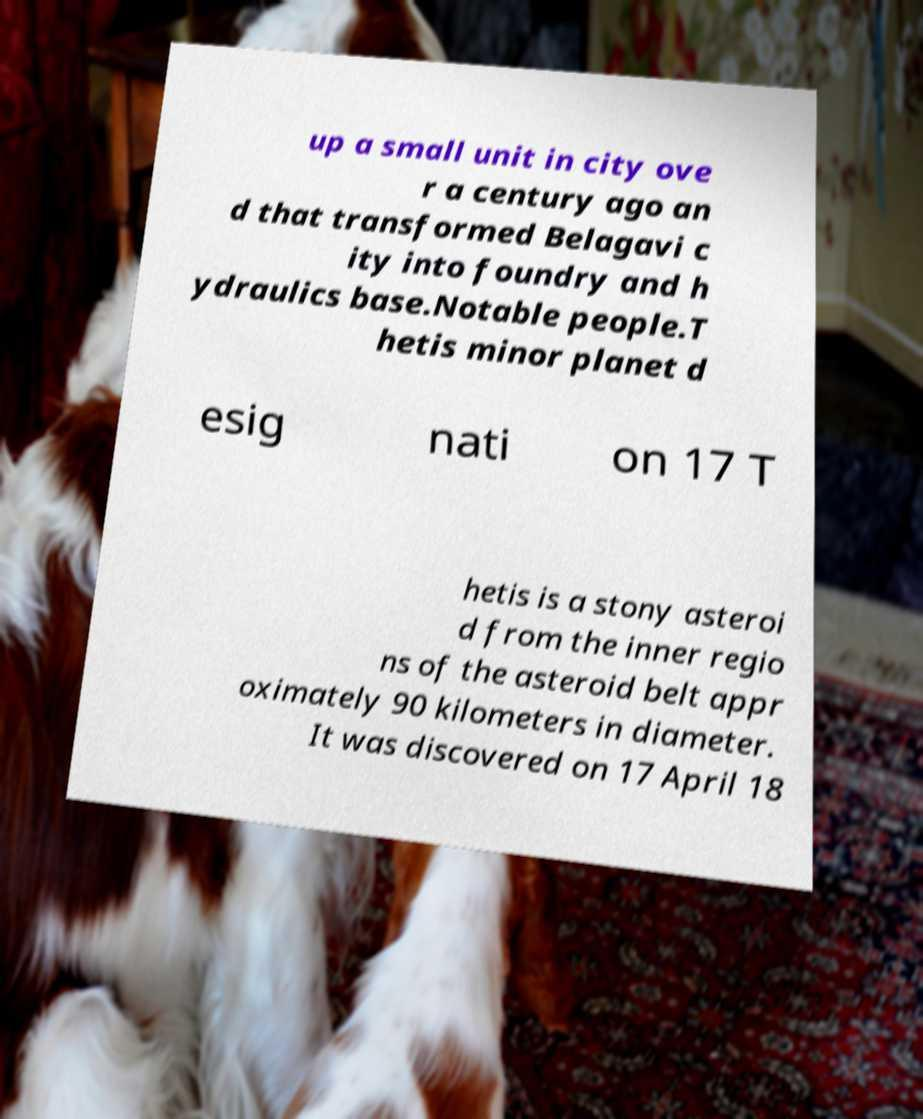Can you accurately transcribe the text from the provided image for me? up a small unit in city ove r a century ago an d that transformed Belagavi c ity into foundry and h ydraulics base.Notable people.T hetis minor planet d esig nati on 17 T hetis is a stony asteroi d from the inner regio ns of the asteroid belt appr oximately 90 kilometers in diameter. It was discovered on 17 April 18 